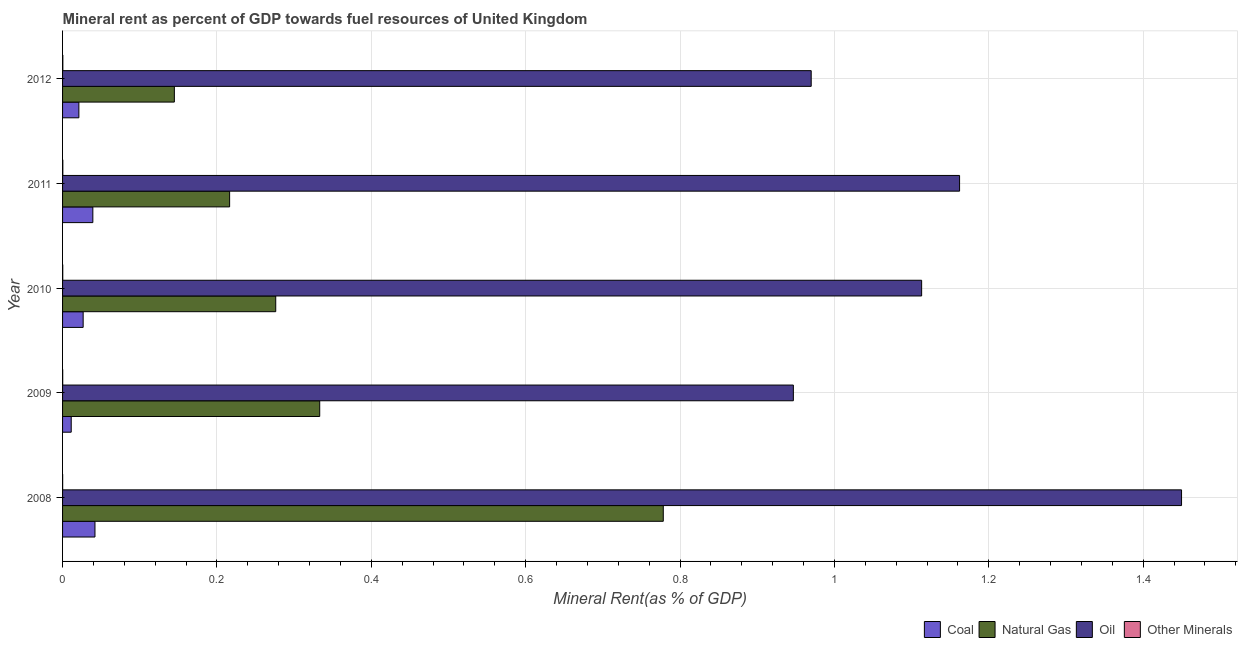How many different coloured bars are there?
Your response must be concise. 4. How many groups of bars are there?
Make the answer very short. 5. How many bars are there on the 2nd tick from the top?
Provide a short and direct response. 4. How many bars are there on the 2nd tick from the bottom?
Make the answer very short. 4. What is the natural gas rent in 2010?
Provide a short and direct response. 0.28. Across all years, what is the maximum natural gas rent?
Give a very brief answer. 0.78. Across all years, what is the minimum  rent of other minerals?
Give a very brief answer. 0. What is the total coal rent in the graph?
Offer a terse response. 0.14. What is the difference between the oil rent in 2008 and that in 2010?
Your response must be concise. 0.34. What is the difference between the oil rent in 2009 and the natural gas rent in 2010?
Your answer should be very brief. 0.67. What is the average natural gas rent per year?
Keep it short and to the point. 0.35. In the year 2012, what is the difference between the oil rent and coal rent?
Ensure brevity in your answer.  0.95. In how many years, is the coal rent greater than 0.52 %?
Offer a terse response. 0. What is the ratio of the oil rent in 2010 to that in 2012?
Provide a short and direct response. 1.15. Is the difference between the oil rent in 2009 and 2011 greater than the difference between the natural gas rent in 2009 and 2011?
Keep it short and to the point. No. What is the difference between the highest and the second highest coal rent?
Offer a very short reply. 0. What is the difference between the highest and the lowest natural gas rent?
Offer a terse response. 0.63. What does the 2nd bar from the top in 2009 represents?
Make the answer very short. Oil. What does the 1st bar from the bottom in 2009 represents?
Provide a succinct answer. Coal. Is it the case that in every year, the sum of the coal rent and natural gas rent is greater than the oil rent?
Keep it short and to the point. No. How many bars are there?
Make the answer very short. 20. How many years are there in the graph?
Offer a very short reply. 5. What is the difference between two consecutive major ticks on the X-axis?
Give a very brief answer. 0.2. Where does the legend appear in the graph?
Ensure brevity in your answer.  Bottom right. How many legend labels are there?
Ensure brevity in your answer.  4. What is the title of the graph?
Provide a succinct answer. Mineral rent as percent of GDP towards fuel resources of United Kingdom. What is the label or title of the X-axis?
Provide a succinct answer. Mineral Rent(as % of GDP). What is the label or title of the Y-axis?
Your response must be concise. Year. What is the Mineral Rent(as % of GDP) in Coal in 2008?
Provide a succinct answer. 0.04. What is the Mineral Rent(as % of GDP) in Natural Gas in 2008?
Offer a terse response. 0.78. What is the Mineral Rent(as % of GDP) of Oil in 2008?
Make the answer very short. 1.45. What is the Mineral Rent(as % of GDP) of Other Minerals in 2008?
Ensure brevity in your answer.  0. What is the Mineral Rent(as % of GDP) in Coal in 2009?
Offer a terse response. 0.01. What is the Mineral Rent(as % of GDP) of Natural Gas in 2009?
Provide a succinct answer. 0.33. What is the Mineral Rent(as % of GDP) in Oil in 2009?
Your answer should be very brief. 0.95. What is the Mineral Rent(as % of GDP) of Other Minerals in 2009?
Your response must be concise. 0. What is the Mineral Rent(as % of GDP) of Coal in 2010?
Ensure brevity in your answer.  0.03. What is the Mineral Rent(as % of GDP) in Natural Gas in 2010?
Provide a short and direct response. 0.28. What is the Mineral Rent(as % of GDP) in Oil in 2010?
Give a very brief answer. 1.11. What is the Mineral Rent(as % of GDP) in Other Minerals in 2010?
Your answer should be compact. 0. What is the Mineral Rent(as % of GDP) in Coal in 2011?
Keep it short and to the point. 0.04. What is the Mineral Rent(as % of GDP) of Natural Gas in 2011?
Your response must be concise. 0.22. What is the Mineral Rent(as % of GDP) of Oil in 2011?
Give a very brief answer. 1.16. What is the Mineral Rent(as % of GDP) in Other Minerals in 2011?
Ensure brevity in your answer.  0. What is the Mineral Rent(as % of GDP) of Coal in 2012?
Your response must be concise. 0.02. What is the Mineral Rent(as % of GDP) in Natural Gas in 2012?
Your response must be concise. 0.14. What is the Mineral Rent(as % of GDP) of Oil in 2012?
Keep it short and to the point. 0.97. What is the Mineral Rent(as % of GDP) in Other Minerals in 2012?
Provide a short and direct response. 0. Across all years, what is the maximum Mineral Rent(as % of GDP) of Coal?
Provide a succinct answer. 0.04. Across all years, what is the maximum Mineral Rent(as % of GDP) in Natural Gas?
Offer a very short reply. 0.78. Across all years, what is the maximum Mineral Rent(as % of GDP) in Oil?
Provide a short and direct response. 1.45. Across all years, what is the maximum Mineral Rent(as % of GDP) in Other Minerals?
Offer a terse response. 0. Across all years, what is the minimum Mineral Rent(as % of GDP) in Coal?
Offer a terse response. 0.01. Across all years, what is the minimum Mineral Rent(as % of GDP) of Natural Gas?
Offer a very short reply. 0.14. Across all years, what is the minimum Mineral Rent(as % of GDP) of Oil?
Ensure brevity in your answer.  0.95. Across all years, what is the minimum Mineral Rent(as % of GDP) of Other Minerals?
Offer a very short reply. 0. What is the total Mineral Rent(as % of GDP) in Coal in the graph?
Keep it short and to the point. 0.14. What is the total Mineral Rent(as % of GDP) of Natural Gas in the graph?
Your answer should be compact. 1.75. What is the total Mineral Rent(as % of GDP) of Oil in the graph?
Your answer should be compact. 5.64. What is the total Mineral Rent(as % of GDP) of Other Minerals in the graph?
Ensure brevity in your answer.  0. What is the difference between the Mineral Rent(as % of GDP) of Coal in 2008 and that in 2009?
Provide a succinct answer. 0.03. What is the difference between the Mineral Rent(as % of GDP) of Natural Gas in 2008 and that in 2009?
Your answer should be very brief. 0.45. What is the difference between the Mineral Rent(as % of GDP) of Oil in 2008 and that in 2009?
Your answer should be compact. 0.5. What is the difference between the Mineral Rent(as % of GDP) in Other Minerals in 2008 and that in 2009?
Keep it short and to the point. -0. What is the difference between the Mineral Rent(as % of GDP) of Coal in 2008 and that in 2010?
Give a very brief answer. 0.02. What is the difference between the Mineral Rent(as % of GDP) in Natural Gas in 2008 and that in 2010?
Make the answer very short. 0.5. What is the difference between the Mineral Rent(as % of GDP) of Oil in 2008 and that in 2010?
Provide a succinct answer. 0.34. What is the difference between the Mineral Rent(as % of GDP) in Other Minerals in 2008 and that in 2010?
Offer a very short reply. -0. What is the difference between the Mineral Rent(as % of GDP) of Coal in 2008 and that in 2011?
Give a very brief answer. 0. What is the difference between the Mineral Rent(as % of GDP) of Natural Gas in 2008 and that in 2011?
Keep it short and to the point. 0.56. What is the difference between the Mineral Rent(as % of GDP) of Oil in 2008 and that in 2011?
Ensure brevity in your answer.  0.29. What is the difference between the Mineral Rent(as % of GDP) in Other Minerals in 2008 and that in 2011?
Offer a terse response. -0. What is the difference between the Mineral Rent(as % of GDP) in Coal in 2008 and that in 2012?
Give a very brief answer. 0.02. What is the difference between the Mineral Rent(as % of GDP) in Natural Gas in 2008 and that in 2012?
Your response must be concise. 0.63. What is the difference between the Mineral Rent(as % of GDP) in Oil in 2008 and that in 2012?
Give a very brief answer. 0.48. What is the difference between the Mineral Rent(as % of GDP) in Other Minerals in 2008 and that in 2012?
Your response must be concise. -0. What is the difference between the Mineral Rent(as % of GDP) of Coal in 2009 and that in 2010?
Provide a short and direct response. -0.02. What is the difference between the Mineral Rent(as % of GDP) in Natural Gas in 2009 and that in 2010?
Make the answer very short. 0.06. What is the difference between the Mineral Rent(as % of GDP) in Oil in 2009 and that in 2010?
Offer a terse response. -0.17. What is the difference between the Mineral Rent(as % of GDP) of Other Minerals in 2009 and that in 2010?
Ensure brevity in your answer.  -0. What is the difference between the Mineral Rent(as % of GDP) in Coal in 2009 and that in 2011?
Your answer should be very brief. -0.03. What is the difference between the Mineral Rent(as % of GDP) of Natural Gas in 2009 and that in 2011?
Give a very brief answer. 0.12. What is the difference between the Mineral Rent(as % of GDP) in Oil in 2009 and that in 2011?
Your answer should be very brief. -0.22. What is the difference between the Mineral Rent(as % of GDP) in Other Minerals in 2009 and that in 2011?
Ensure brevity in your answer.  -0. What is the difference between the Mineral Rent(as % of GDP) of Coal in 2009 and that in 2012?
Provide a short and direct response. -0.01. What is the difference between the Mineral Rent(as % of GDP) in Natural Gas in 2009 and that in 2012?
Ensure brevity in your answer.  0.19. What is the difference between the Mineral Rent(as % of GDP) of Oil in 2009 and that in 2012?
Provide a short and direct response. -0.02. What is the difference between the Mineral Rent(as % of GDP) of Other Minerals in 2009 and that in 2012?
Your answer should be compact. -0. What is the difference between the Mineral Rent(as % of GDP) of Coal in 2010 and that in 2011?
Keep it short and to the point. -0.01. What is the difference between the Mineral Rent(as % of GDP) in Natural Gas in 2010 and that in 2011?
Your answer should be very brief. 0.06. What is the difference between the Mineral Rent(as % of GDP) of Oil in 2010 and that in 2011?
Provide a short and direct response. -0.05. What is the difference between the Mineral Rent(as % of GDP) of Other Minerals in 2010 and that in 2011?
Offer a terse response. -0. What is the difference between the Mineral Rent(as % of GDP) in Coal in 2010 and that in 2012?
Keep it short and to the point. 0.01. What is the difference between the Mineral Rent(as % of GDP) in Natural Gas in 2010 and that in 2012?
Your response must be concise. 0.13. What is the difference between the Mineral Rent(as % of GDP) in Oil in 2010 and that in 2012?
Give a very brief answer. 0.14. What is the difference between the Mineral Rent(as % of GDP) in Other Minerals in 2010 and that in 2012?
Ensure brevity in your answer.  -0. What is the difference between the Mineral Rent(as % of GDP) of Coal in 2011 and that in 2012?
Your answer should be compact. 0.02. What is the difference between the Mineral Rent(as % of GDP) of Natural Gas in 2011 and that in 2012?
Offer a very short reply. 0.07. What is the difference between the Mineral Rent(as % of GDP) of Oil in 2011 and that in 2012?
Your response must be concise. 0.19. What is the difference between the Mineral Rent(as % of GDP) of Other Minerals in 2011 and that in 2012?
Ensure brevity in your answer.  -0. What is the difference between the Mineral Rent(as % of GDP) of Coal in 2008 and the Mineral Rent(as % of GDP) of Natural Gas in 2009?
Offer a very short reply. -0.29. What is the difference between the Mineral Rent(as % of GDP) in Coal in 2008 and the Mineral Rent(as % of GDP) in Oil in 2009?
Offer a terse response. -0.9. What is the difference between the Mineral Rent(as % of GDP) of Coal in 2008 and the Mineral Rent(as % of GDP) of Other Minerals in 2009?
Provide a short and direct response. 0.04. What is the difference between the Mineral Rent(as % of GDP) in Natural Gas in 2008 and the Mineral Rent(as % of GDP) in Oil in 2009?
Offer a terse response. -0.17. What is the difference between the Mineral Rent(as % of GDP) of Natural Gas in 2008 and the Mineral Rent(as % of GDP) of Other Minerals in 2009?
Make the answer very short. 0.78. What is the difference between the Mineral Rent(as % of GDP) of Oil in 2008 and the Mineral Rent(as % of GDP) of Other Minerals in 2009?
Offer a very short reply. 1.45. What is the difference between the Mineral Rent(as % of GDP) in Coal in 2008 and the Mineral Rent(as % of GDP) in Natural Gas in 2010?
Your response must be concise. -0.23. What is the difference between the Mineral Rent(as % of GDP) of Coal in 2008 and the Mineral Rent(as % of GDP) of Oil in 2010?
Give a very brief answer. -1.07. What is the difference between the Mineral Rent(as % of GDP) of Coal in 2008 and the Mineral Rent(as % of GDP) of Other Minerals in 2010?
Provide a succinct answer. 0.04. What is the difference between the Mineral Rent(as % of GDP) of Natural Gas in 2008 and the Mineral Rent(as % of GDP) of Oil in 2010?
Your answer should be compact. -0.33. What is the difference between the Mineral Rent(as % of GDP) of Natural Gas in 2008 and the Mineral Rent(as % of GDP) of Other Minerals in 2010?
Provide a short and direct response. 0.78. What is the difference between the Mineral Rent(as % of GDP) in Oil in 2008 and the Mineral Rent(as % of GDP) in Other Minerals in 2010?
Offer a terse response. 1.45. What is the difference between the Mineral Rent(as % of GDP) of Coal in 2008 and the Mineral Rent(as % of GDP) of Natural Gas in 2011?
Offer a very short reply. -0.17. What is the difference between the Mineral Rent(as % of GDP) in Coal in 2008 and the Mineral Rent(as % of GDP) in Oil in 2011?
Make the answer very short. -1.12. What is the difference between the Mineral Rent(as % of GDP) in Coal in 2008 and the Mineral Rent(as % of GDP) in Other Minerals in 2011?
Offer a very short reply. 0.04. What is the difference between the Mineral Rent(as % of GDP) in Natural Gas in 2008 and the Mineral Rent(as % of GDP) in Oil in 2011?
Ensure brevity in your answer.  -0.38. What is the difference between the Mineral Rent(as % of GDP) of Natural Gas in 2008 and the Mineral Rent(as % of GDP) of Other Minerals in 2011?
Your answer should be very brief. 0.78. What is the difference between the Mineral Rent(as % of GDP) of Oil in 2008 and the Mineral Rent(as % of GDP) of Other Minerals in 2011?
Provide a succinct answer. 1.45. What is the difference between the Mineral Rent(as % of GDP) in Coal in 2008 and the Mineral Rent(as % of GDP) in Natural Gas in 2012?
Ensure brevity in your answer.  -0.1. What is the difference between the Mineral Rent(as % of GDP) of Coal in 2008 and the Mineral Rent(as % of GDP) of Oil in 2012?
Keep it short and to the point. -0.93. What is the difference between the Mineral Rent(as % of GDP) in Coal in 2008 and the Mineral Rent(as % of GDP) in Other Minerals in 2012?
Offer a very short reply. 0.04. What is the difference between the Mineral Rent(as % of GDP) of Natural Gas in 2008 and the Mineral Rent(as % of GDP) of Oil in 2012?
Offer a very short reply. -0.19. What is the difference between the Mineral Rent(as % of GDP) in Natural Gas in 2008 and the Mineral Rent(as % of GDP) in Other Minerals in 2012?
Your answer should be compact. 0.78. What is the difference between the Mineral Rent(as % of GDP) in Oil in 2008 and the Mineral Rent(as % of GDP) in Other Minerals in 2012?
Provide a short and direct response. 1.45. What is the difference between the Mineral Rent(as % of GDP) in Coal in 2009 and the Mineral Rent(as % of GDP) in Natural Gas in 2010?
Provide a succinct answer. -0.26. What is the difference between the Mineral Rent(as % of GDP) of Coal in 2009 and the Mineral Rent(as % of GDP) of Oil in 2010?
Your response must be concise. -1.1. What is the difference between the Mineral Rent(as % of GDP) in Coal in 2009 and the Mineral Rent(as % of GDP) in Other Minerals in 2010?
Give a very brief answer. 0.01. What is the difference between the Mineral Rent(as % of GDP) in Natural Gas in 2009 and the Mineral Rent(as % of GDP) in Oil in 2010?
Offer a very short reply. -0.78. What is the difference between the Mineral Rent(as % of GDP) in Natural Gas in 2009 and the Mineral Rent(as % of GDP) in Other Minerals in 2010?
Make the answer very short. 0.33. What is the difference between the Mineral Rent(as % of GDP) in Oil in 2009 and the Mineral Rent(as % of GDP) in Other Minerals in 2010?
Your answer should be very brief. 0.95. What is the difference between the Mineral Rent(as % of GDP) in Coal in 2009 and the Mineral Rent(as % of GDP) in Natural Gas in 2011?
Keep it short and to the point. -0.21. What is the difference between the Mineral Rent(as % of GDP) of Coal in 2009 and the Mineral Rent(as % of GDP) of Oil in 2011?
Give a very brief answer. -1.15. What is the difference between the Mineral Rent(as % of GDP) in Coal in 2009 and the Mineral Rent(as % of GDP) in Other Minerals in 2011?
Your answer should be compact. 0.01. What is the difference between the Mineral Rent(as % of GDP) of Natural Gas in 2009 and the Mineral Rent(as % of GDP) of Oil in 2011?
Your response must be concise. -0.83. What is the difference between the Mineral Rent(as % of GDP) of Natural Gas in 2009 and the Mineral Rent(as % of GDP) of Other Minerals in 2011?
Offer a very short reply. 0.33. What is the difference between the Mineral Rent(as % of GDP) in Oil in 2009 and the Mineral Rent(as % of GDP) in Other Minerals in 2011?
Make the answer very short. 0.95. What is the difference between the Mineral Rent(as % of GDP) in Coal in 2009 and the Mineral Rent(as % of GDP) in Natural Gas in 2012?
Keep it short and to the point. -0.13. What is the difference between the Mineral Rent(as % of GDP) in Coal in 2009 and the Mineral Rent(as % of GDP) in Oil in 2012?
Provide a succinct answer. -0.96. What is the difference between the Mineral Rent(as % of GDP) in Coal in 2009 and the Mineral Rent(as % of GDP) in Other Minerals in 2012?
Your answer should be very brief. 0.01. What is the difference between the Mineral Rent(as % of GDP) of Natural Gas in 2009 and the Mineral Rent(as % of GDP) of Oil in 2012?
Ensure brevity in your answer.  -0.64. What is the difference between the Mineral Rent(as % of GDP) in Natural Gas in 2009 and the Mineral Rent(as % of GDP) in Other Minerals in 2012?
Give a very brief answer. 0.33. What is the difference between the Mineral Rent(as % of GDP) of Oil in 2009 and the Mineral Rent(as % of GDP) of Other Minerals in 2012?
Make the answer very short. 0.95. What is the difference between the Mineral Rent(as % of GDP) in Coal in 2010 and the Mineral Rent(as % of GDP) in Natural Gas in 2011?
Provide a short and direct response. -0.19. What is the difference between the Mineral Rent(as % of GDP) in Coal in 2010 and the Mineral Rent(as % of GDP) in Oil in 2011?
Ensure brevity in your answer.  -1.14. What is the difference between the Mineral Rent(as % of GDP) in Coal in 2010 and the Mineral Rent(as % of GDP) in Other Minerals in 2011?
Your answer should be very brief. 0.03. What is the difference between the Mineral Rent(as % of GDP) in Natural Gas in 2010 and the Mineral Rent(as % of GDP) in Oil in 2011?
Make the answer very short. -0.89. What is the difference between the Mineral Rent(as % of GDP) in Natural Gas in 2010 and the Mineral Rent(as % of GDP) in Other Minerals in 2011?
Offer a very short reply. 0.28. What is the difference between the Mineral Rent(as % of GDP) of Oil in 2010 and the Mineral Rent(as % of GDP) of Other Minerals in 2011?
Offer a terse response. 1.11. What is the difference between the Mineral Rent(as % of GDP) of Coal in 2010 and the Mineral Rent(as % of GDP) of Natural Gas in 2012?
Give a very brief answer. -0.12. What is the difference between the Mineral Rent(as % of GDP) of Coal in 2010 and the Mineral Rent(as % of GDP) of Oil in 2012?
Provide a succinct answer. -0.94. What is the difference between the Mineral Rent(as % of GDP) of Coal in 2010 and the Mineral Rent(as % of GDP) of Other Minerals in 2012?
Offer a very short reply. 0.03. What is the difference between the Mineral Rent(as % of GDP) in Natural Gas in 2010 and the Mineral Rent(as % of GDP) in Oil in 2012?
Provide a succinct answer. -0.69. What is the difference between the Mineral Rent(as % of GDP) of Natural Gas in 2010 and the Mineral Rent(as % of GDP) of Other Minerals in 2012?
Give a very brief answer. 0.28. What is the difference between the Mineral Rent(as % of GDP) in Oil in 2010 and the Mineral Rent(as % of GDP) in Other Minerals in 2012?
Your answer should be very brief. 1.11. What is the difference between the Mineral Rent(as % of GDP) of Coal in 2011 and the Mineral Rent(as % of GDP) of Natural Gas in 2012?
Your response must be concise. -0.11. What is the difference between the Mineral Rent(as % of GDP) in Coal in 2011 and the Mineral Rent(as % of GDP) in Oil in 2012?
Make the answer very short. -0.93. What is the difference between the Mineral Rent(as % of GDP) of Coal in 2011 and the Mineral Rent(as % of GDP) of Other Minerals in 2012?
Give a very brief answer. 0.04. What is the difference between the Mineral Rent(as % of GDP) of Natural Gas in 2011 and the Mineral Rent(as % of GDP) of Oil in 2012?
Provide a short and direct response. -0.75. What is the difference between the Mineral Rent(as % of GDP) of Natural Gas in 2011 and the Mineral Rent(as % of GDP) of Other Minerals in 2012?
Your answer should be very brief. 0.22. What is the difference between the Mineral Rent(as % of GDP) of Oil in 2011 and the Mineral Rent(as % of GDP) of Other Minerals in 2012?
Your answer should be very brief. 1.16. What is the average Mineral Rent(as % of GDP) in Coal per year?
Keep it short and to the point. 0.03. What is the average Mineral Rent(as % of GDP) of Natural Gas per year?
Make the answer very short. 0.35. What is the average Mineral Rent(as % of GDP) of Oil per year?
Your response must be concise. 1.13. What is the average Mineral Rent(as % of GDP) in Other Minerals per year?
Your response must be concise. 0. In the year 2008, what is the difference between the Mineral Rent(as % of GDP) in Coal and Mineral Rent(as % of GDP) in Natural Gas?
Your answer should be very brief. -0.74. In the year 2008, what is the difference between the Mineral Rent(as % of GDP) of Coal and Mineral Rent(as % of GDP) of Oil?
Your response must be concise. -1.41. In the year 2008, what is the difference between the Mineral Rent(as % of GDP) of Coal and Mineral Rent(as % of GDP) of Other Minerals?
Keep it short and to the point. 0.04. In the year 2008, what is the difference between the Mineral Rent(as % of GDP) of Natural Gas and Mineral Rent(as % of GDP) of Oil?
Offer a very short reply. -0.67. In the year 2008, what is the difference between the Mineral Rent(as % of GDP) of Natural Gas and Mineral Rent(as % of GDP) of Other Minerals?
Offer a terse response. 0.78. In the year 2008, what is the difference between the Mineral Rent(as % of GDP) of Oil and Mineral Rent(as % of GDP) of Other Minerals?
Your answer should be compact. 1.45. In the year 2009, what is the difference between the Mineral Rent(as % of GDP) in Coal and Mineral Rent(as % of GDP) in Natural Gas?
Your answer should be very brief. -0.32. In the year 2009, what is the difference between the Mineral Rent(as % of GDP) of Coal and Mineral Rent(as % of GDP) of Oil?
Your answer should be very brief. -0.94. In the year 2009, what is the difference between the Mineral Rent(as % of GDP) of Coal and Mineral Rent(as % of GDP) of Other Minerals?
Your response must be concise. 0.01. In the year 2009, what is the difference between the Mineral Rent(as % of GDP) in Natural Gas and Mineral Rent(as % of GDP) in Oil?
Provide a short and direct response. -0.61. In the year 2009, what is the difference between the Mineral Rent(as % of GDP) of Natural Gas and Mineral Rent(as % of GDP) of Other Minerals?
Your answer should be compact. 0.33. In the year 2009, what is the difference between the Mineral Rent(as % of GDP) in Oil and Mineral Rent(as % of GDP) in Other Minerals?
Keep it short and to the point. 0.95. In the year 2010, what is the difference between the Mineral Rent(as % of GDP) in Coal and Mineral Rent(as % of GDP) in Natural Gas?
Your response must be concise. -0.25. In the year 2010, what is the difference between the Mineral Rent(as % of GDP) in Coal and Mineral Rent(as % of GDP) in Oil?
Your response must be concise. -1.09. In the year 2010, what is the difference between the Mineral Rent(as % of GDP) of Coal and Mineral Rent(as % of GDP) of Other Minerals?
Provide a succinct answer. 0.03. In the year 2010, what is the difference between the Mineral Rent(as % of GDP) of Natural Gas and Mineral Rent(as % of GDP) of Oil?
Make the answer very short. -0.84. In the year 2010, what is the difference between the Mineral Rent(as % of GDP) of Natural Gas and Mineral Rent(as % of GDP) of Other Minerals?
Ensure brevity in your answer.  0.28. In the year 2010, what is the difference between the Mineral Rent(as % of GDP) of Oil and Mineral Rent(as % of GDP) of Other Minerals?
Ensure brevity in your answer.  1.11. In the year 2011, what is the difference between the Mineral Rent(as % of GDP) in Coal and Mineral Rent(as % of GDP) in Natural Gas?
Make the answer very short. -0.18. In the year 2011, what is the difference between the Mineral Rent(as % of GDP) in Coal and Mineral Rent(as % of GDP) in Oil?
Your response must be concise. -1.12. In the year 2011, what is the difference between the Mineral Rent(as % of GDP) of Coal and Mineral Rent(as % of GDP) of Other Minerals?
Offer a very short reply. 0.04. In the year 2011, what is the difference between the Mineral Rent(as % of GDP) in Natural Gas and Mineral Rent(as % of GDP) in Oil?
Offer a very short reply. -0.95. In the year 2011, what is the difference between the Mineral Rent(as % of GDP) of Natural Gas and Mineral Rent(as % of GDP) of Other Minerals?
Make the answer very short. 0.22. In the year 2011, what is the difference between the Mineral Rent(as % of GDP) in Oil and Mineral Rent(as % of GDP) in Other Minerals?
Your response must be concise. 1.16. In the year 2012, what is the difference between the Mineral Rent(as % of GDP) in Coal and Mineral Rent(as % of GDP) in Natural Gas?
Your response must be concise. -0.12. In the year 2012, what is the difference between the Mineral Rent(as % of GDP) of Coal and Mineral Rent(as % of GDP) of Oil?
Ensure brevity in your answer.  -0.95. In the year 2012, what is the difference between the Mineral Rent(as % of GDP) of Coal and Mineral Rent(as % of GDP) of Other Minerals?
Provide a succinct answer. 0.02. In the year 2012, what is the difference between the Mineral Rent(as % of GDP) in Natural Gas and Mineral Rent(as % of GDP) in Oil?
Your response must be concise. -0.82. In the year 2012, what is the difference between the Mineral Rent(as % of GDP) of Natural Gas and Mineral Rent(as % of GDP) of Other Minerals?
Make the answer very short. 0.14. In the year 2012, what is the difference between the Mineral Rent(as % of GDP) of Oil and Mineral Rent(as % of GDP) of Other Minerals?
Offer a very short reply. 0.97. What is the ratio of the Mineral Rent(as % of GDP) in Coal in 2008 to that in 2009?
Make the answer very short. 3.74. What is the ratio of the Mineral Rent(as % of GDP) of Natural Gas in 2008 to that in 2009?
Your response must be concise. 2.34. What is the ratio of the Mineral Rent(as % of GDP) of Oil in 2008 to that in 2009?
Offer a terse response. 1.53. What is the ratio of the Mineral Rent(as % of GDP) in Other Minerals in 2008 to that in 2009?
Provide a succinct answer. 0.65. What is the ratio of the Mineral Rent(as % of GDP) of Coal in 2008 to that in 2010?
Make the answer very short. 1.57. What is the ratio of the Mineral Rent(as % of GDP) of Natural Gas in 2008 to that in 2010?
Your answer should be compact. 2.82. What is the ratio of the Mineral Rent(as % of GDP) of Oil in 2008 to that in 2010?
Your answer should be compact. 1.3. What is the ratio of the Mineral Rent(as % of GDP) of Other Minerals in 2008 to that in 2010?
Give a very brief answer. 0.53. What is the ratio of the Mineral Rent(as % of GDP) of Coal in 2008 to that in 2011?
Ensure brevity in your answer.  1.07. What is the ratio of the Mineral Rent(as % of GDP) in Natural Gas in 2008 to that in 2011?
Your response must be concise. 3.6. What is the ratio of the Mineral Rent(as % of GDP) of Oil in 2008 to that in 2011?
Your answer should be very brief. 1.25. What is the ratio of the Mineral Rent(as % of GDP) in Other Minerals in 2008 to that in 2011?
Offer a very short reply. 0.37. What is the ratio of the Mineral Rent(as % of GDP) in Coal in 2008 to that in 2012?
Your answer should be very brief. 1.99. What is the ratio of the Mineral Rent(as % of GDP) of Natural Gas in 2008 to that in 2012?
Ensure brevity in your answer.  5.37. What is the ratio of the Mineral Rent(as % of GDP) of Oil in 2008 to that in 2012?
Offer a very short reply. 1.49. What is the ratio of the Mineral Rent(as % of GDP) in Other Minerals in 2008 to that in 2012?
Make the answer very short. 0.34. What is the ratio of the Mineral Rent(as % of GDP) in Coal in 2009 to that in 2010?
Make the answer very short. 0.42. What is the ratio of the Mineral Rent(as % of GDP) in Natural Gas in 2009 to that in 2010?
Your answer should be compact. 1.21. What is the ratio of the Mineral Rent(as % of GDP) of Oil in 2009 to that in 2010?
Keep it short and to the point. 0.85. What is the ratio of the Mineral Rent(as % of GDP) in Other Minerals in 2009 to that in 2010?
Your answer should be compact. 0.81. What is the ratio of the Mineral Rent(as % of GDP) in Coal in 2009 to that in 2011?
Your answer should be very brief. 0.29. What is the ratio of the Mineral Rent(as % of GDP) in Natural Gas in 2009 to that in 2011?
Your response must be concise. 1.54. What is the ratio of the Mineral Rent(as % of GDP) in Oil in 2009 to that in 2011?
Keep it short and to the point. 0.81. What is the ratio of the Mineral Rent(as % of GDP) in Other Minerals in 2009 to that in 2011?
Keep it short and to the point. 0.57. What is the ratio of the Mineral Rent(as % of GDP) of Coal in 2009 to that in 2012?
Provide a short and direct response. 0.53. What is the ratio of the Mineral Rent(as % of GDP) of Natural Gas in 2009 to that in 2012?
Provide a succinct answer. 2.3. What is the ratio of the Mineral Rent(as % of GDP) in Oil in 2009 to that in 2012?
Provide a short and direct response. 0.98. What is the ratio of the Mineral Rent(as % of GDP) in Other Minerals in 2009 to that in 2012?
Offer a terse response. 0.52. What is the ratio of the Mineral Rent(as % of GDP) in Coal in 2010 to that in 2011?
Offer a very short reply. 0.68. What is the ratio of the Mineral Rent(as % of GDP) in Natural Gas in 2010 to that in 2011?
Offer a terse response. 1.28. What is the ratio of the Mineral Rent(as % of GDP) of Oil in 2010 to that in 2011?
Ensure brevity in your answer.  0.96. What is the ratio of the Mineral Rent(as % of GDP) in Other Minerals in 2010 to that in 2011?
Provide a short and direct response. 0.7. What is the ratio of the Mineral Rent(as % of GDP) of Coal in 2010 to that in 2012?
Give a very brief answer. 1.26. What is the ratio of the Mineral Rent(as % of GDP) of Natural Gas in 2010 to that in 2012?
Your response must be concise. 1.91. What is the ratio of the Mineral Rent(as % of GDP) in Oil in 2010 to that in 2012?
Give a very brief answer. 1.15. What is the ratio of the Mineral Rent(as % of GDP) of Other Minerals in 2010 to that in 2012?
Your answer should be very brief. 0.63. What is the ratio of the Mineral Rent(as % of GDP) of Coal in 2011 to that in 2012?
Your answer should be very brief. 1.86. What is the ratio of the Mineral Rent(as % of GDP) in Natural Gas in 2011 to that in 2012?
Offer a very short reply. 1.49. What is the ratio of the Mineral Rent(as % of GDP) in Oil in 2011 to that in 2012?
Keep it short and to the point. 1.2. What is the ratio of the Mineral Rent(as % of GDP) of Other Minerals in 2011 to that in 2012?
Give a very brief answer. 0.91. What is the difference between the highest and the second highest Mineral Rent(as % of GDP) in Coal?
Keep it short and to the point. 0. What is the difference between the highest and the second highest Mineral Rent(as % of GDP) in Natural Gas?
Keep it short and to the point. 0.45. What is the difference between the highest and the second highest Mineral Rent(as % of GDP) of Oil?
Your answer should be compact. 0.29. What is the difference between the highest and the lowest Mineral Rent(as % of GDP) of Coal?
Give a very brief answer. 0.03. What is the difference between the highest and the lowest Mineral Rent(as % of GDP) in Natural Gas?
Provide a short and direct response. 0.63. What is the difference between the highest and the lowest Mineral Rent(as % of GDP) in Oil?
Give a very brief answer. 0.5. 